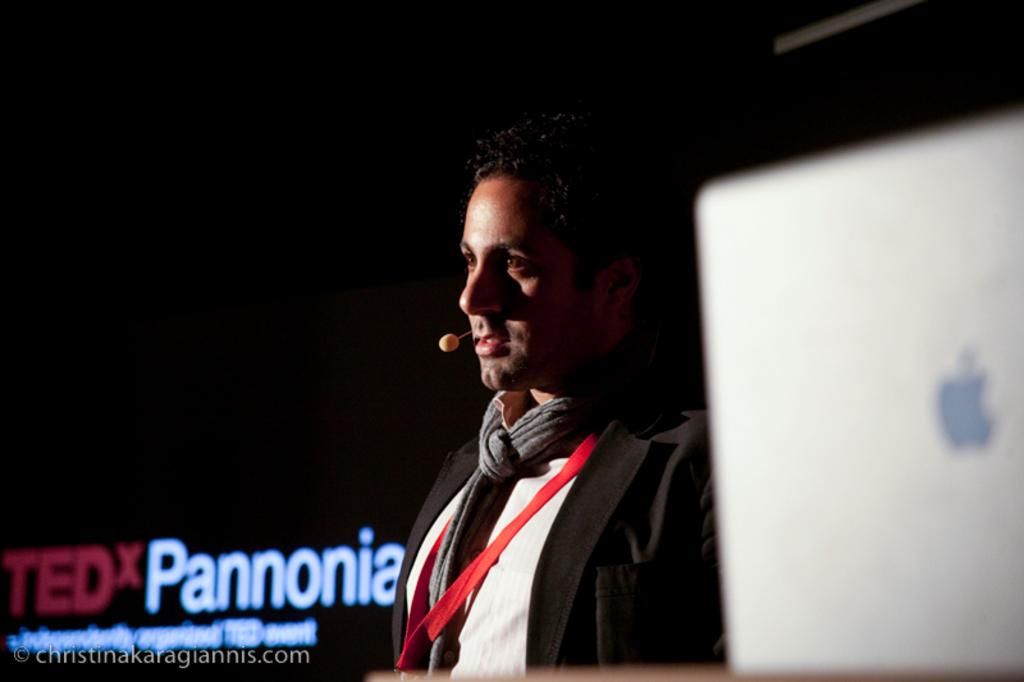Who is the main subject in the image? There is a man in the middle of the image. What is the man wearing that identifies him? The man is wearing an ID card. What is the man holding in the image? The man is wearing a mic. What can be seen behind the man in the image? There is text visible behind the man. What electronic device is present on the right side of the image? There is a laptop on the right side of the image. How would you describe the lighting in the image? The background of the image is dark. Can you see a snake slithering across the floor in the image? There is no snake present in the image. What type of club is the man holding in the image? The man is not holding a club in the image; he is wearing a mic. 